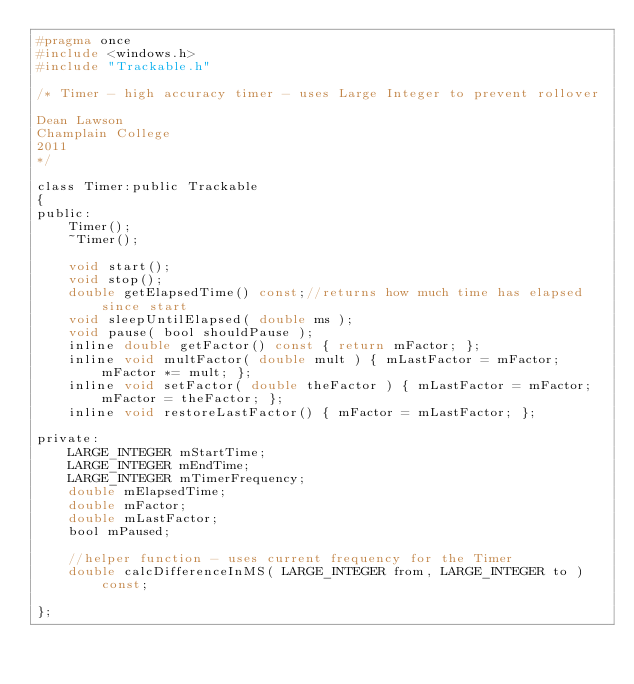<code> <loc_0><loc_0><loc_500><loc_500><_C_>#pragma once
#include <windows.h>
#include "Trackable.h"

/* Timer - high accuracy timer - uses Large Integer to prevent rollover

Dean Lawson
Champlain College
2011
*/

class Timer:public Trackable
{
public:
	Timer();
	~Timer();

	void start();
	void stop();
	double getElapsedTime() const;//returns how much time has elapsed since start
	void sleepUntilElapsed( double ms );
	void pause( bool shouldPause );
	inline double getFactor() const { return mFactor; };
	inline void multFactor( double mult ) { mLastFactor = mFactor; mFactor *= mult; };
	inline void setFactor( double theFactor ) { mLastFactor = mFactor; mFactor = theFactor; };
	inline void restoreLastFactor() { mFactor = mLastFactor; };

private:
	LARGE_INTEGER mStartTime;
	LARGE_INTEGER mEndTime;
	LARGE_INTEGER mTimerFrequency;
	double mElapsedTime;
	double mFactor;
	double mLastFactor;
	bool mPaused;

	//helper function - uses current frequency for the Timer
	double calcDifferenceInMS( LARGE_INTEGER from, LARGE_INTEGER to ) const;

};</code> 